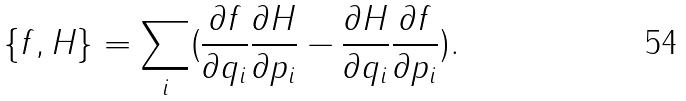<formula> <loc_0><loc_0><loc_500><loc_500>\{ f , H \} = \sum _ { i } ( \frac { \partial f } { \partial q _ { i } } \frac { \partial H } { \partial p _ { i } } - \frac { \partial H } { \partial q _ { i } } \frac { \partial f } { \partial p _ { i } } ) .</formula> 